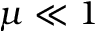<formula> <loc_0><loc_0><loc_500><loc_500>\mu \ll 1</formula> 